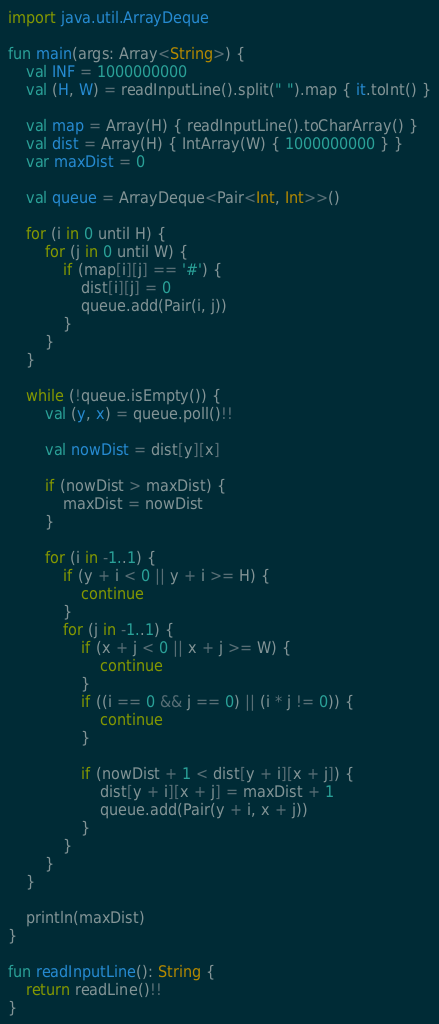<code> <loc_0><loc_0><loc_500><loc_500><_Kotlin_>import java.util.ArrayDeque

fun main(args: Array<String>) {
    val INF = 1000000000
    val (H, W) = readInputLine().split(" ").map { it.toInt() }
    
    val map = Array(H) { readInputLine().toCharArray() }
    val dist = Array(H) { IntArray(W) { 1000000000 } }
    var maxDist = 0
    
    val queue = ArrayDeque<Pair<Int, Int>>()
    
    for (i in 0 until H) {
        for (j in 0 until W) {
            if (map[i][j] == '#') {
                dist[i][j] = 0
                queue.add(Pair(i, j))
            }
        }
    }

    while (!queue.isEmpty()) {
        val (y, x) = queue.poll()!!
        
        val nowDist = dist[y][x]
        
        if (nowDist > maxDist) {
            maxDist = nowDist
        }
        
        for (i in -1..1) {
            if (y + i < 0 || y + i >= H) {
                continue
            }
            for (j in -1..1) {
                if (x + j < 0 || x + j >= W) {
                    continue
                }
                if ((i == 0 && j == 0) || (i * j != 0)) {
                    continue
                }
                
                if (nowDist + 1 < dist[y + i][x + j]) {
                    dist[y + i][x + j] = maxDist + 1
                    queue.add(Pair(y + i, x + j))
                }
            }
        }
    }
    
    println(maxDist)
}

fun readInputLine(): String {
    return readLine()!!
}
</code> 